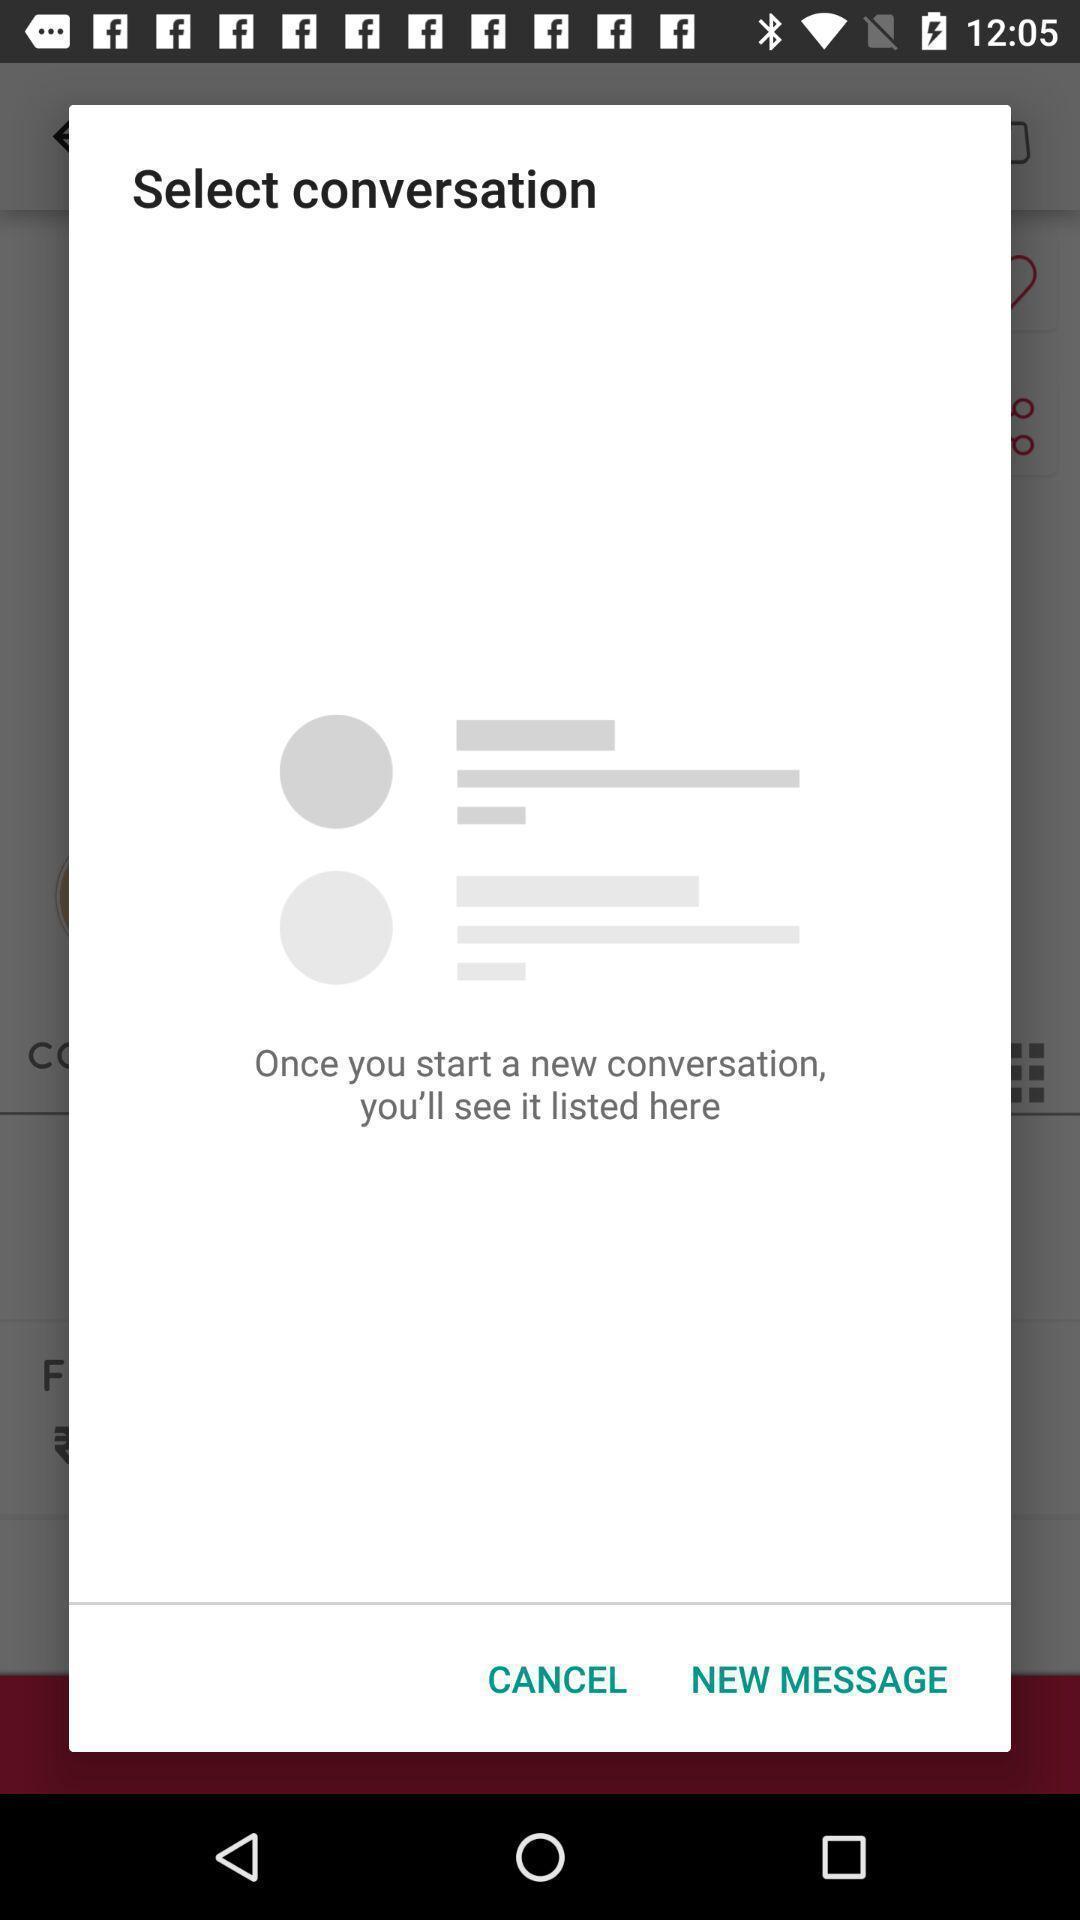Summarize the information in this screenshot. Select conversation page in beauty app. 